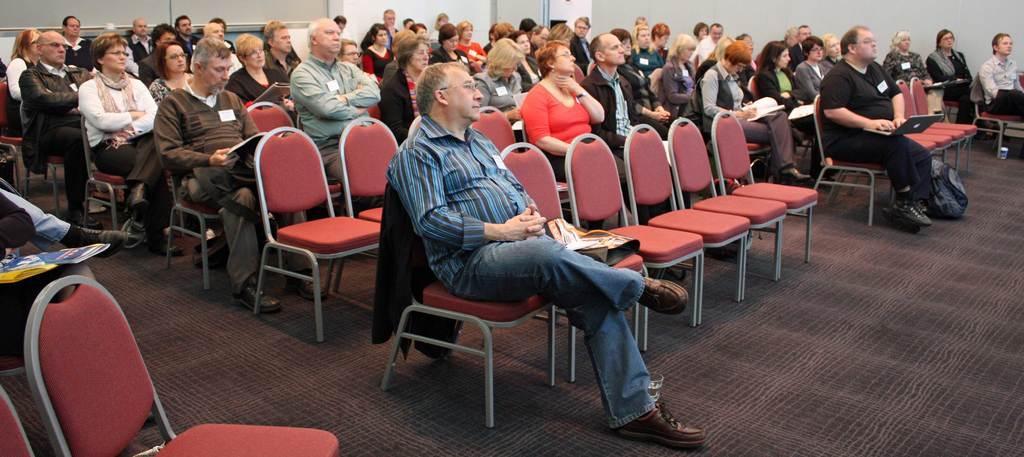Please provide a concise description of this image. In this image I can see group of people sitting on the chairs. There are few empty chairs. These chairs are made of red cushion. I can see a bag placed on the floor. The floor was covered up with the carpet. 